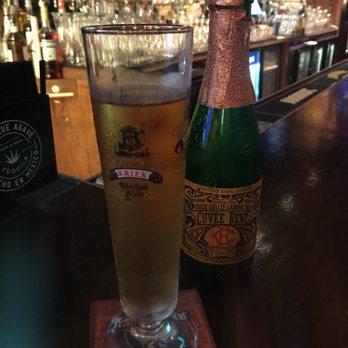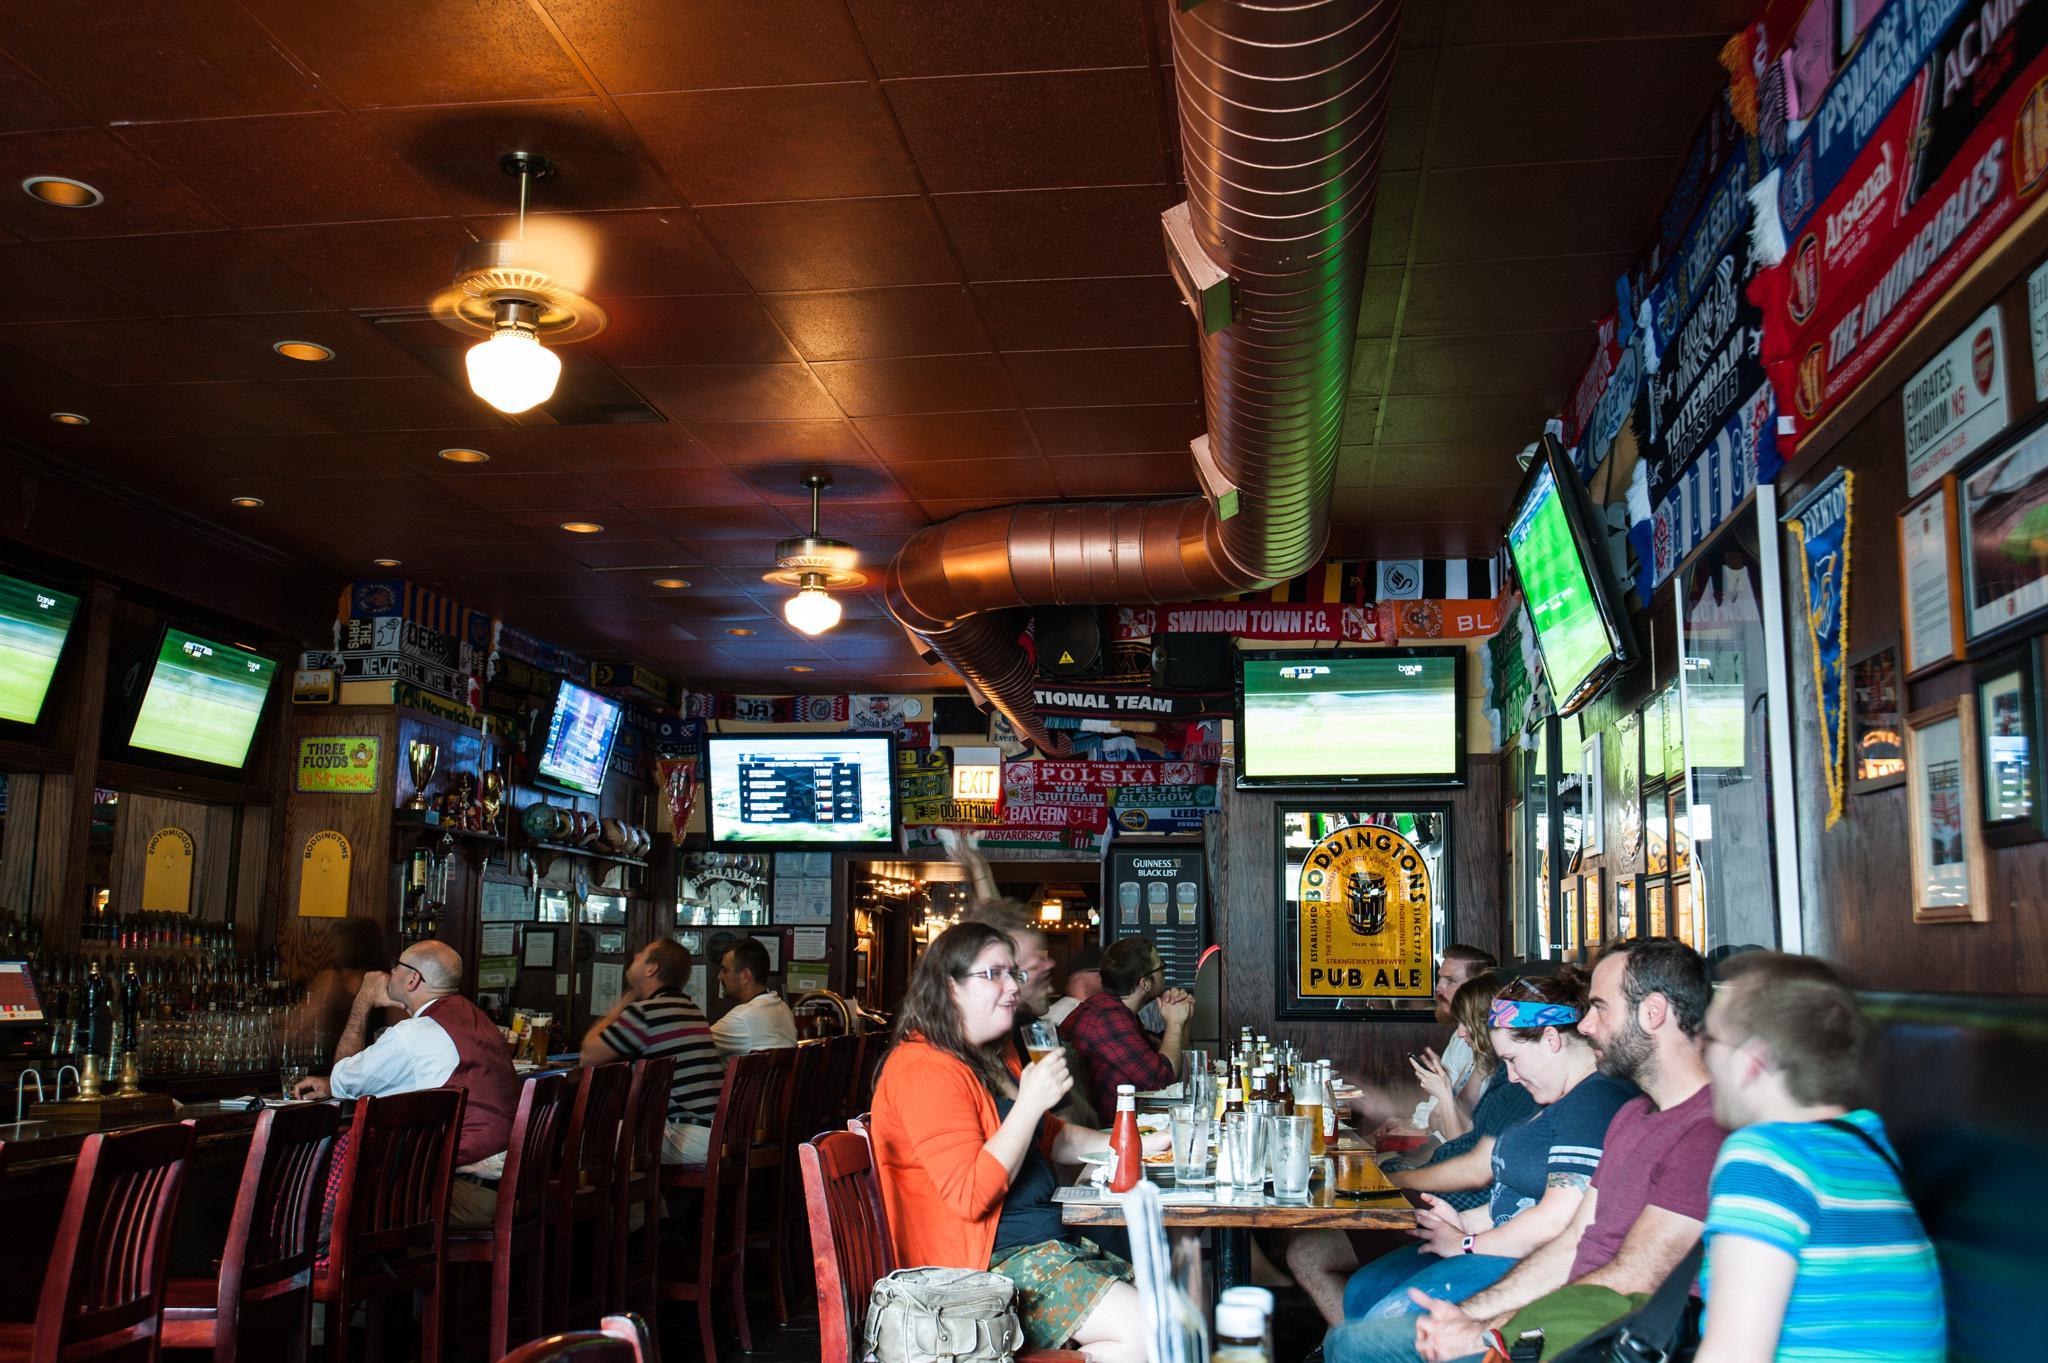The first image is the image on the left, the second image is the image on the right. For the images displayed, is the sentence "In at least one image there are three people at the bar looking at a television." factually correct? Answer yes or no. Yes. The first image is the image on the left, the second image is the image on the right. Considering the images on both sides, is "There are televisions in exactly one of the imagtes." valid? Answer yes or no. Yes. 